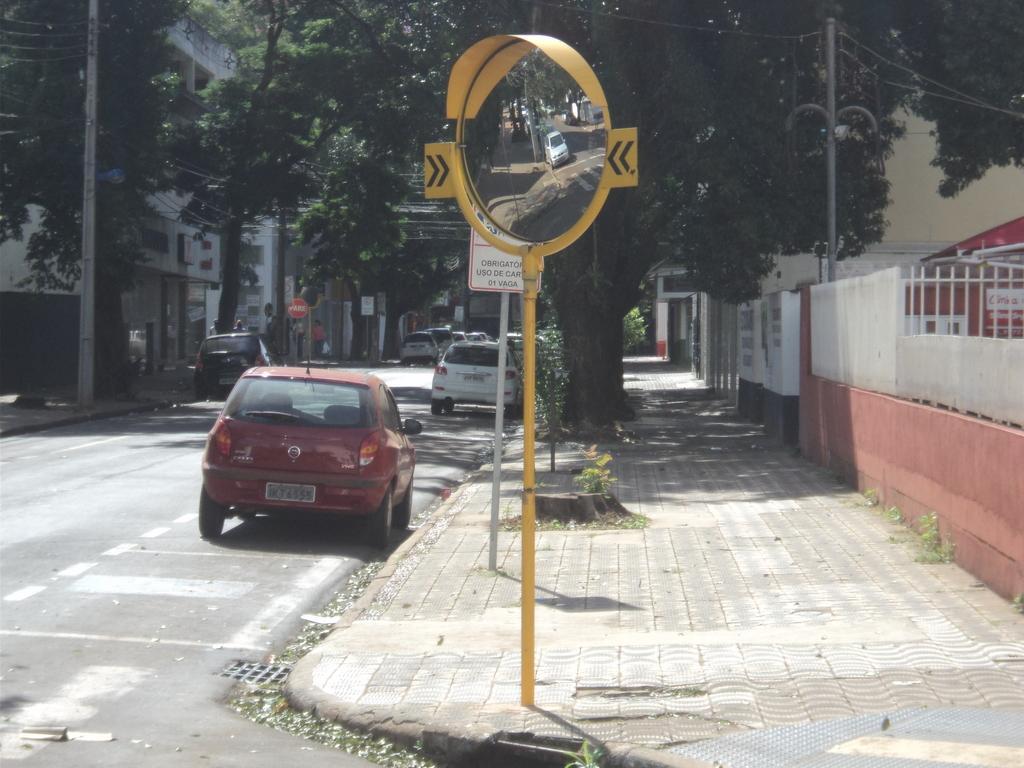How would you summarize this image in a sentence or two? In this image, we can see vehicles on the road and in the background, there are people. In the background, there are trees, buildings and we can see boards and there are railings and we can see poles along with wires. 